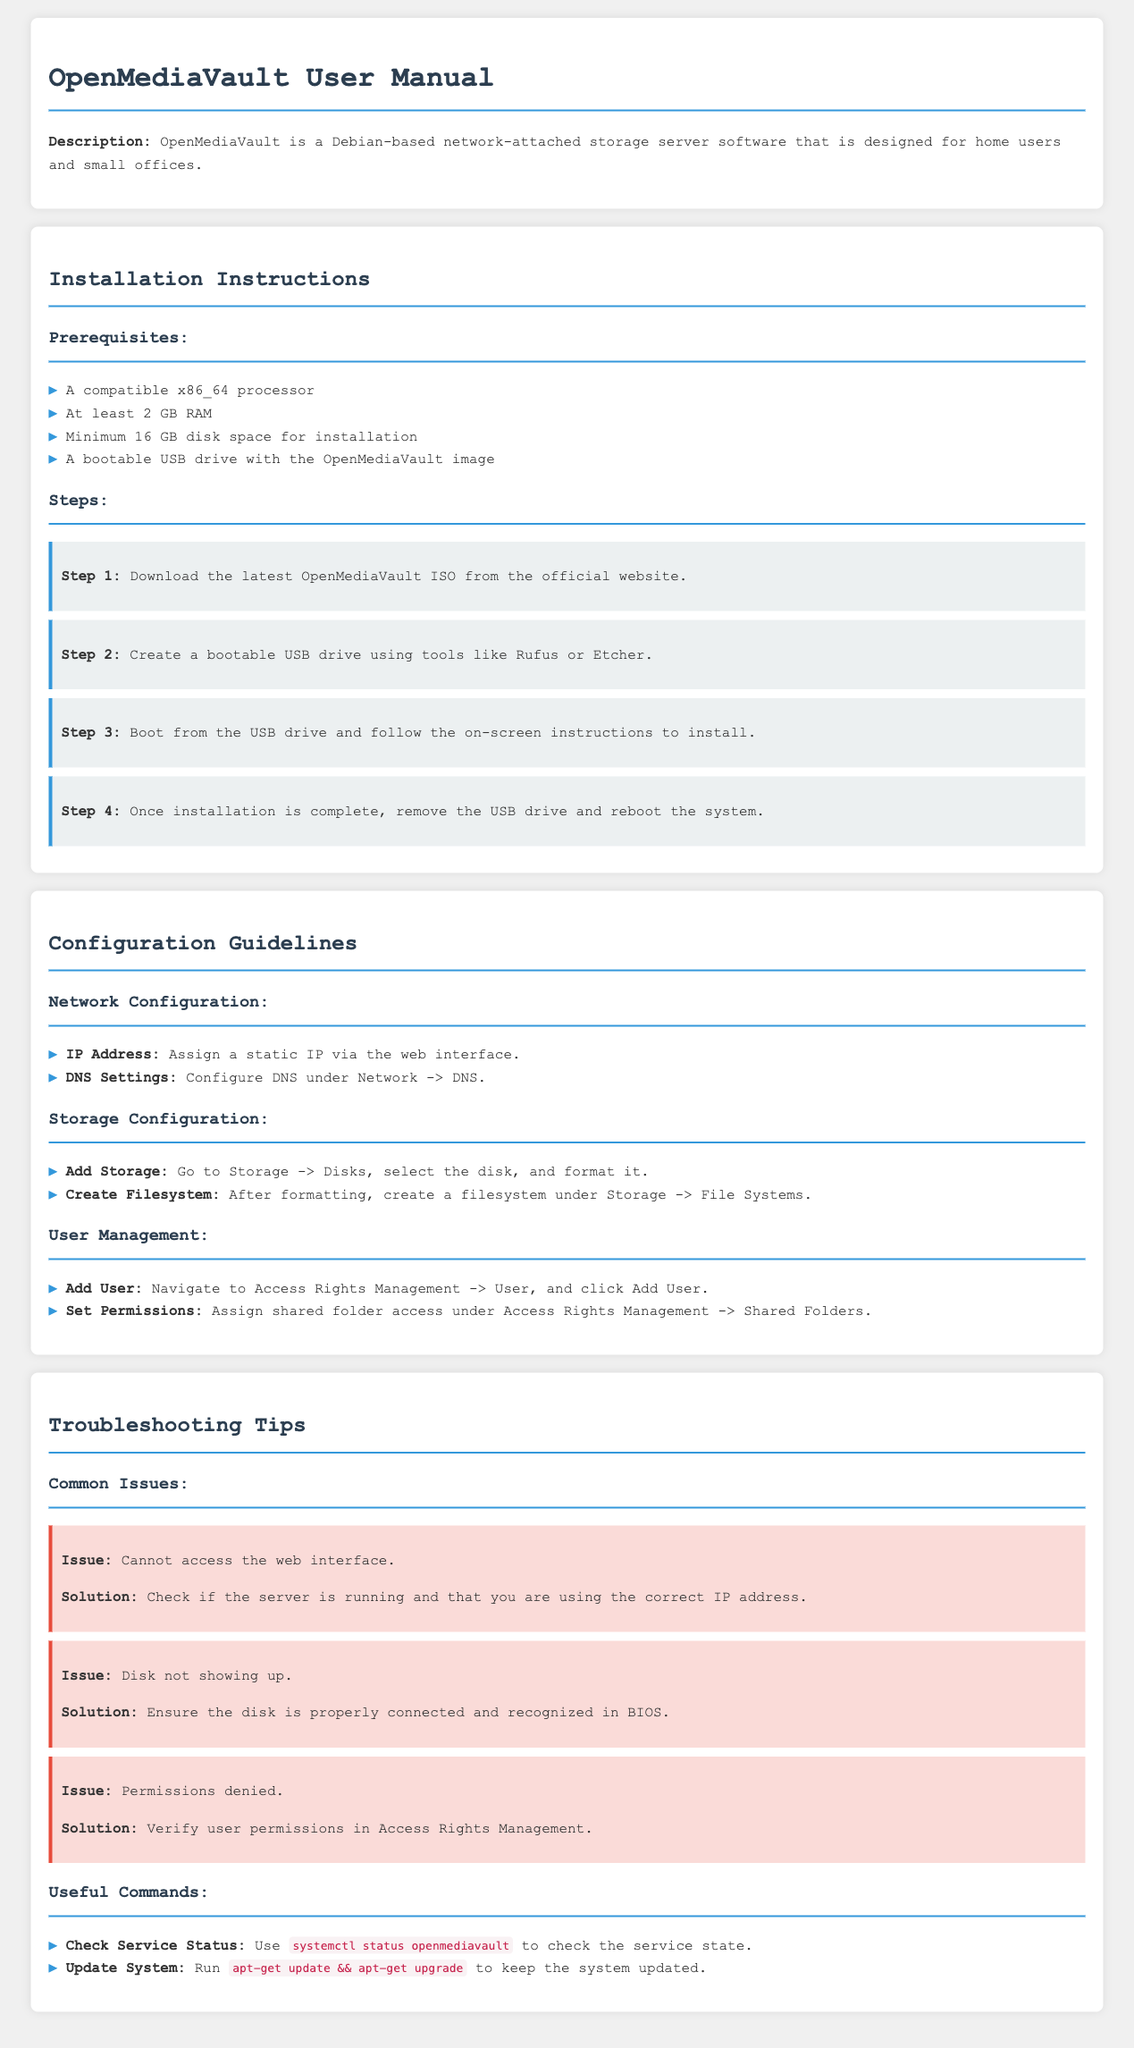What is the minimum disk space required for installation? The document states that the minimum disk space required for installation is 16 GB.
Answer: 16 GB What is the first step in the installation instructions? The document lists that the first step is to download the latest OpenMediaVault ISO from the official website.
Answer: Download the latest OpenMediaVault ISO Where can you configure DNS settings? According to the document, DNS settings can be configured under Network -> DNS.
Answer: Network -> DNS What command is used to update the system? The document specifies that the command to update the system is apt-get update && apt-get upgrade.
Answer: apt-get update && apt-get upgrade What is a common issue with a solution provided in the document? The document describes the common issue of "Cannot access the web interface," along with its solution.
Answer: Cannot access the web interface How many steps are there in the installation instructions? The document outlines four steps in the installation instructions.
Answer: Four steps What section includes information on User Management? The document indicates that information on User Management is included in the Configuration Guidelines section.
Answer: Configuration Guidelines Which processor type is required for installation? The document mentions that a compatible x86_64 processor is required for installation.
Answer: x86_64 processor What should you do if the disk does not show up? The document advises ensuring that the disk is properly connected and recognized in BIOS if it does not show up.
Answer: Ensure the disk is properly connected 